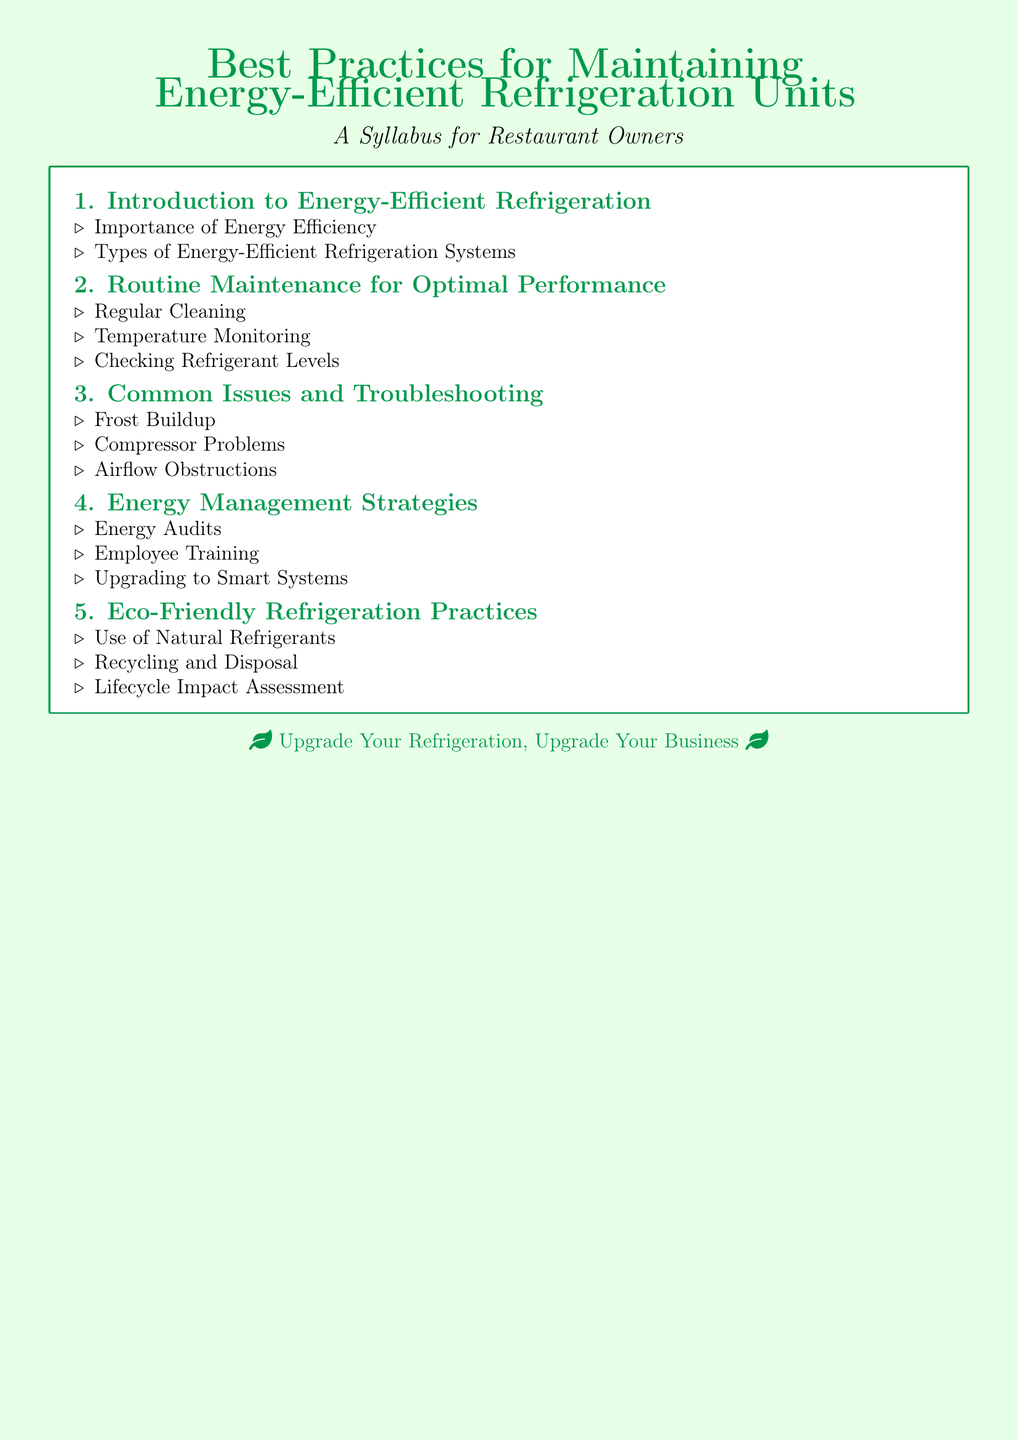What is the title of the syllabus? The title is the main header of the document and states the focus of the syllabus.
Answer: Best Practices for Maintaining Energy-Efficient Refrigeration Units How many modules are included in the syllabus? The number of modules is found by counting the sections outlined in the syllabus.
Answer: 5 What is the first module about? The first module is described at the beginning of the syllabus, indicating its topic.
Answer: Introduction to Energy-Efficient Refrigeration What issue is addressed in module 3? The content of module 3 specifically mentions the problems related to refrigeration units.
Answer: Common Issues and Troubleshooting What is one of the practices mentioned in the eco-friendly refrigeration module? This refers to specific practices listed in the eco-friendly section of the syllabus.
Answer: Use of Natural Refrigerants What is emphasized in the energy management strategies? This question focuses on the key points within that module to find a relevant item.
Answer: Energy Audits Which section discusses temperature monitoring? The section refers to routine maintenance as highlighted in the syllabus.
Answer: Routine Maintenance for Optimal Performance What color theme is used for the document? The question seeks to identify the overall aesthetic based on color usage.
Answer: Cool green and light green 